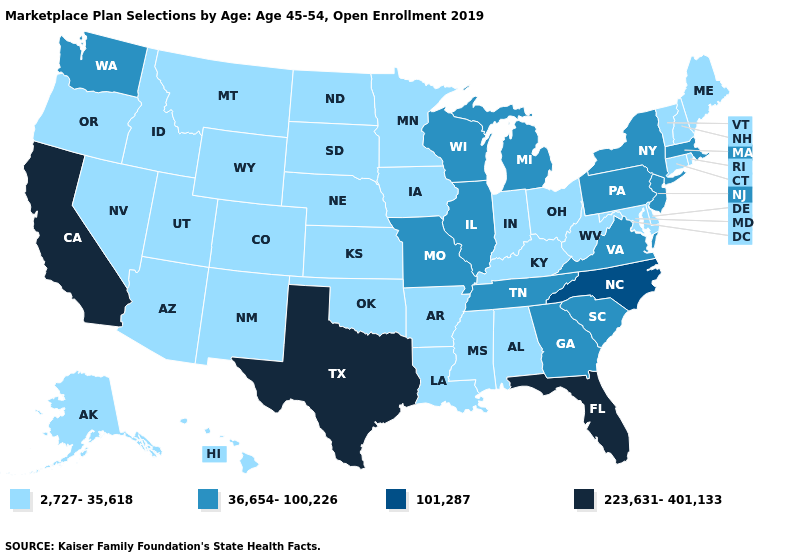Does the first symbol in the legend represent the smallest category?
Short answer required. Yes. Does the map have missing data?
Short answer required. No. What is the highest value in the West ?
Be succinct. 223,631-401,133. Name the states that have a value in the range 36,654-100,226?
Write a very short answer. Georgia, Illinois, Massachusetts, Michigan, Missouri, New Jersey, New York, Pennsylvania, South Carolina, Tennessee, Virginia, Washington, Wisconsin. What is the lowest value in the USA?
Keep it brief. 2,727-35,618. Name the states that have a value in the range 101,287?
Short answer required. North Carolina. Does Louisiana have a lower value than Delaware?
Answer briefly. No. Name the states that have a value in the range 36,654-100,226?
Quick response, please. Georgia, Illinois, Massachusetts, Michigan, Missouri, New Jersey, New York, Pennsylvania, South Carolina, Tennessee, Virginia, Washington, Wisconsin. Does Kansas have the highest value in the MidWest?
Concise answer only. No. What is the lowest value in the West?
Quick response, please. 2,727-35,618. Does Michigan have a higher value than Illinois?
Give a very brief answer. No. Which states have the lowest value in the USA?
Write a very short answer. Alabama, Alaska, Arizona, Arkansas, Colorado, Connecticut, Delaware, Hawaii, Idaho, Indiana, Iowa, Kansas, Kentucky, Louisiana, Maine, Maryland, Minnesota, Mississippi, Montana, Nebraska, Nevada, New Hampshire, New Mexico, North Dakota, Ohio, Oklahoma, Oregon, Rhode Island, South Dakota, Utah, Vermont, West Virginia, Wyoming. Name the states that have a value in the range 36,654-100,226?
Concise answer only. Georgia, Illinois, Massachusetts, Michigan, Missouri, New Jersey, New York, Pennsylvania, South Carolina, Tennessee, Virginia, Washington, Wisconsin. Name the states that have a value in the range 2,727-35,618?
Answer briefly. Alabama, Alaska, Arizona, Arkansas, Colorado, Connecticut, Delaware, Hawaii, Idaho, Indiana, Iowa, Kansas, Kentucky, Louisiana, Maine, Maryland, Minnesota, Mississippi, Montana, Nebraska, Nevada, New Hampshire, New Mexico, North Dakota, Ohio, Oklahoma, Oregon, Rhode Island, South Dakota, Utah, Vermont, West Virginia, Wyoming. 